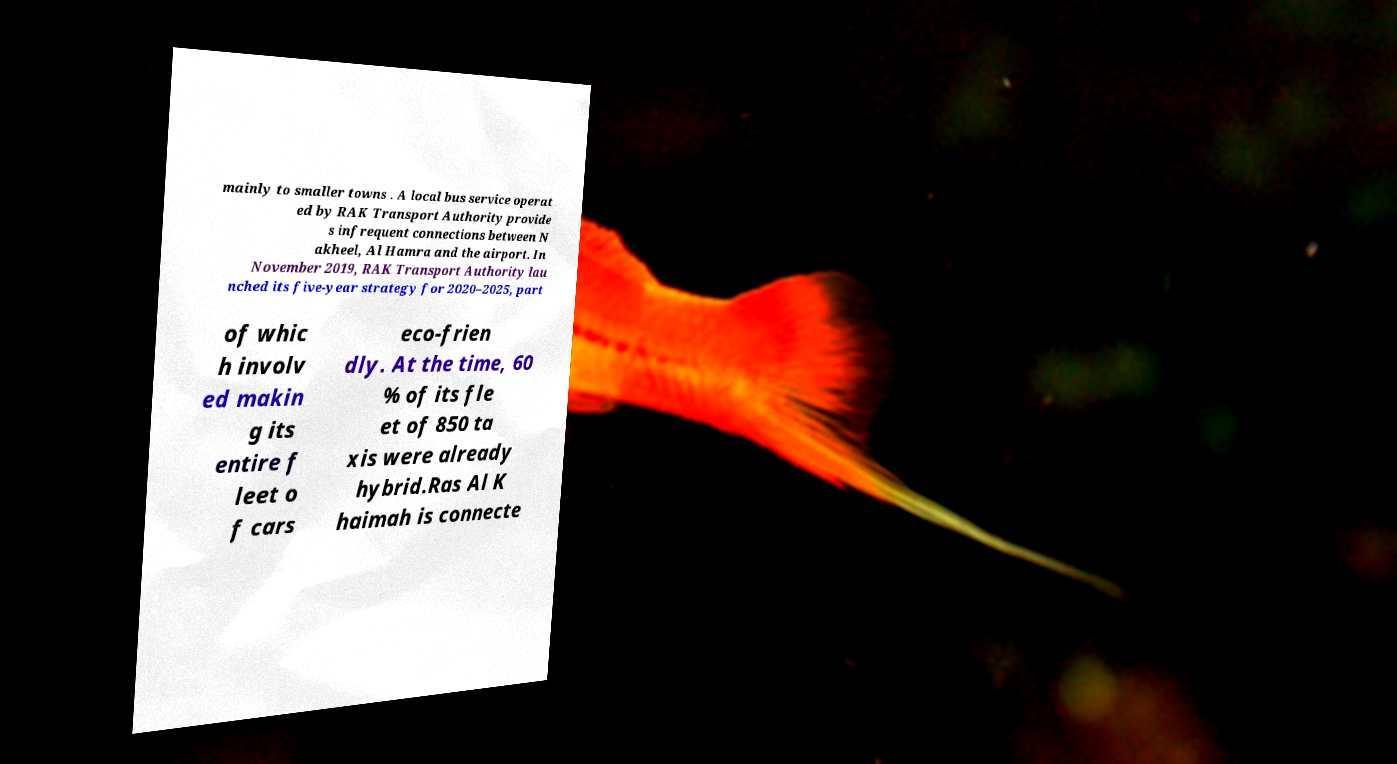For documentation purposes, I need the text within this image transcribed. Could you provide that? mainly to smaller towns . A local bus service operat ed by RAK Transport Authority provide s infrequent connections between N akheel, Al Hamra and the airport. In November 2019, RAK Transport Authority lau nched its five-year strategy for 2020–2025, part of whic h involv ed makin g its entire f leet o f cars eco-frien dly. At the time, 60 % of its fle et of 850 ta xis were already hybrid.Ras Al K haimah is connecte 